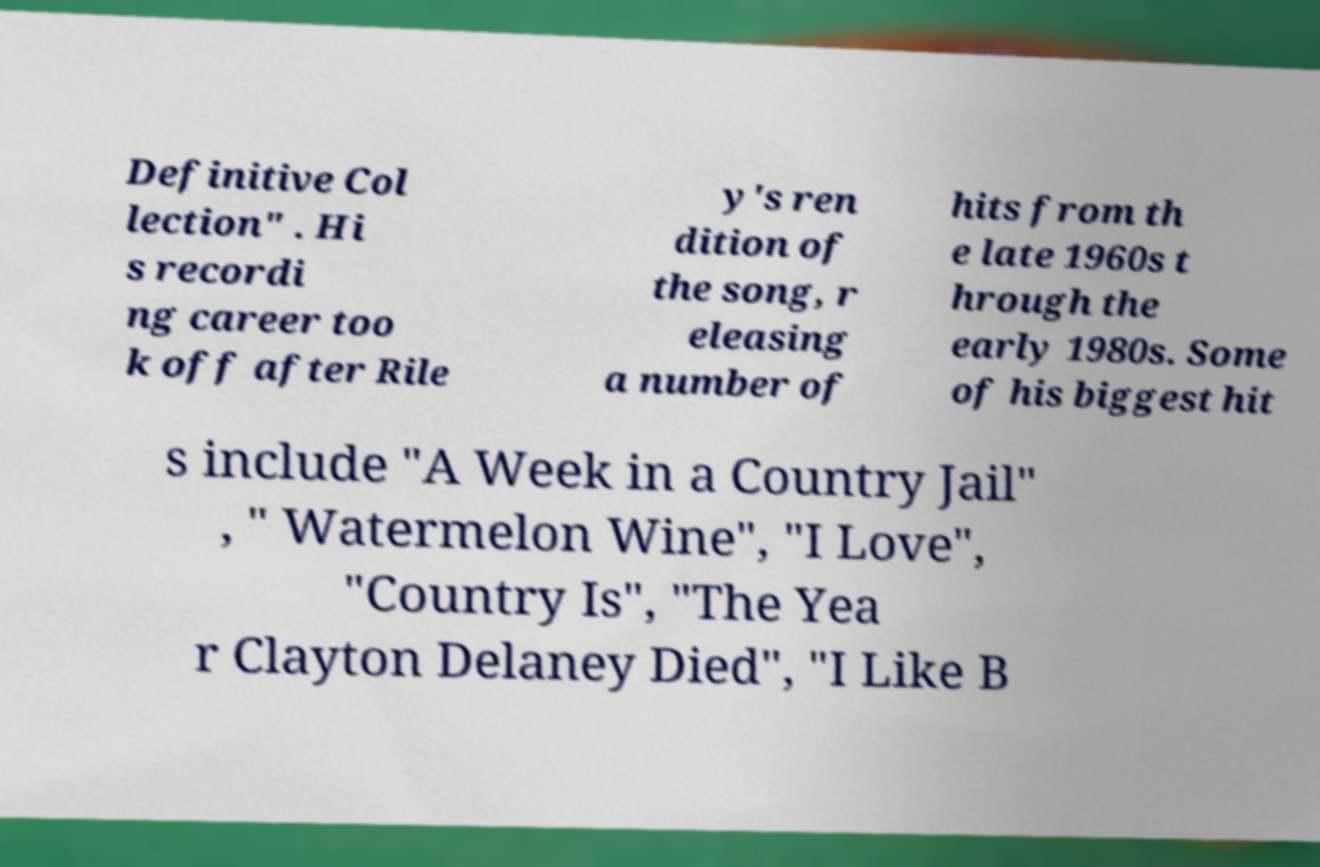For documentation purposes, I need the text within this image transcribed. Could you provide that? Definitive Col lection" . Hi s recordi ng career too k off after Rile y's ren dition of the song, r eleasing a number of hits from th e late 1960s t hrough the early 1980s. Some of his biggest hit s include "A Week in a Country Jail" , " Watermelon Wine", "I Love", "Country Is", "The Yea r Clayton Delaney Died", "I Like B 